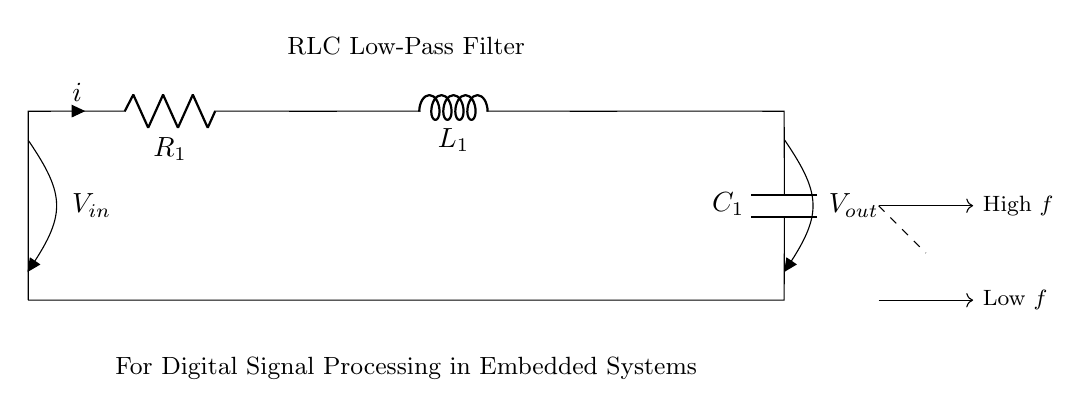What are the components in this circuit? The circuit consists of a resistor, inductor, and capacitor, indicated by R, L, and C symbols in the diagram.
Answer: Resistor, Inductor, Capacitor What is the output voltage labeled as? The output voltage is labeled as V out, which is the potential difference measured across the capacitor.
Answer: V out What is the value of the input voltage? The input voltage is labeled as V in, shown at the top of the circuit diagram where the voltage is supplied.
Answer: V in What is the role of the resistor in this low-pass filter? The resistor limits the current in the circuit and helps set the cutoff frequency for the filter, affecting how quickly the circuit reacts to changes in input.
Answer: Limit current, set cutoff frequency What happens to high-frequency signals in this filter? High-frequency signals are attenuated or blocked by the filter, allowing only low-frequency signals to pass, due to the properties of the RLC components working together.
Answer: Attenuated or blocked What happens to low-frequency signals in this filter? Low-frequency signals pass through with minimal resistance, reaching the output, due to the design of the filter that allows low frequencies to transmit effectively.
Answer: Pass through What frequency response characterizes this RLC circuit? The circuit exhibits a low-pass frequency response, which means it allows signals below a certain cutoff frequency to pass while attenuating frequencies above that threshold.
Answer: Low-pass frequency response 